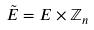Convert formula to latex. <formula><loc_0><loc_0><loc_500><loc_500>\tilde { E } = E \times \mathbb { Z } _ { n }</formula> 